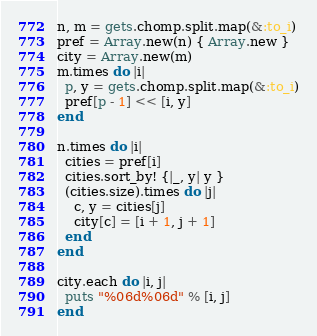<code> <loc_0><loc_0><loc_500><loc_500><_Ruby_>n, m = gets.chomp.split.map(&:to_i)
pref = Array.new(n) { Array.new }
city = Array.new(m)
m.times do |i|
  p, y = gets.chomp.split.map(&:to_i)
  pref[p - 1] << [i, y]
end

n.times do |i|
  cities = pref[i]  
  cities.sort_by! {|_, y| y }
  (cities.size).times do |j|
    c, y = cities[j]
    city[c] = [i + 1, j + 1]
  end
end

city.each do |i, j|
  puts "%06d%06d" % [i, j]
end</code> 